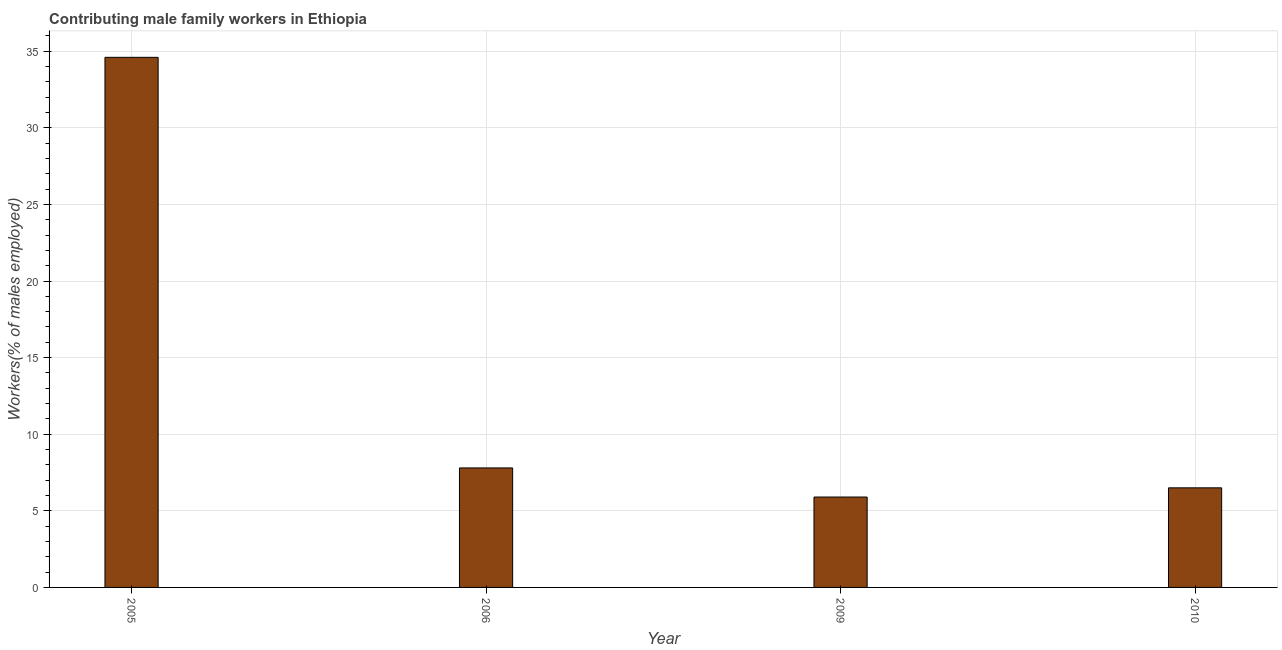Does the graph contain grids?
Your answer should be compact. Yes. What is the title of the graph?
Your response must be concise. Contributing male family workers in Ethiopia. What is the label or title of the X-axis?
Provide a succinct answer. Year. What is the label or title of the Y-axis?
Your answer should be compact. Workers(% of males employed). What is the contributing male family workers in 2009?
Keep it short and to the point. 5.9. Across all years, what is the maximum contributing male family workers?
Provide a short and direct response. 34.6. Across all years, what is the minimum contributing male family workers?
Make the answer very short. 5.9. In which year was the contributing male family workers maximum?
Ensure brevity in your answer.  2005. What is the sum of the contributing male family workers?
Your answer should be very brief. 54.8. What is the average contributing male family workers per year?
Your response must be concise. 13.7. What is the median contributing male family workers?
Offer a terse response. 7.15. What is the ratio of the contributing male family workers in 2005 to that in 2010?
Your answer should be very brief. 5.32. What is the difference between the highest and the second highest contributing male family workers?
Your answer should be very brief. 26.8. What is the difference between the highest and the lowest contributing male family workers?
Provide a succinct answer. 28.7. Are all the bars in the graph horizontal?
Provide a short and direct response. No. How many years are there in the graph?
Make the answer very short. 4. What is the Workers(% of males employed) of 2005?
Your answer should be very brief. 34.6. What is the Workers(% of males employed) of 2006?
Offer a terse response. 7.8. What is the Workers(% of males employed) in 2009?
Your answer should be compact. 5.9. What is the difference between the Workers(% of males employed) in 2005 and 2006?
Offer a terse response. 26.8. What is the difference between the Workers(% of males employed) in 2005 and 2009?
Make the answer very short. 28.7. What is the difference between the Workers(% of males employed) in 2005 and 2010?
Your response must be concise. 28.1. What is the difference between the Workers(% of males employed) in 2006 and 2009?
Offer a terse response. 1.9. What is the difference between the Workers(% of males employed) in 2006 and 2010?
Make the answer very short. 1.3. What is the ratio of the Workers(% of males employed) in 2005 to that in 2006?
Provide a succinct answer. 4.44. What is the ratio of the Workers(% of males employed) in 2005 to that in 2009?
Your answer should be very brief. 5.86. What is the ratio of the Workers(% of males employed) in 2005 to that in 2010?
Offer a very short reply. 5.32. What is the ratio of the Workers(% of males employed) in 2006 to that in 2009?
Offer a terse response. 1.32. What is the ratio of the Workers(% of males employed) in 2009 to that in 2010?
Your response must be concise. 0.91. 